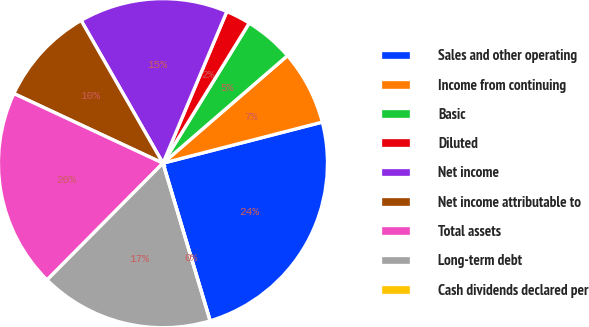Convert chart. <chart><loc_0><loc_0><loc_500><loc_500><pie_chart><fcel>Sales and other operating<fcel>Income from continuing<fcel>Basic<fcel>Diluted<fcel>Net income<fcel>Net income attributable to<fcel>Total assets<fcel>Long-term debt<fcel>Cash dividends declared per<nl><fcel>24.39%<fcel>7.32%<fcel>4.88%<fcel>2.44%<fcel>14.63%<fcel>9.76%<fcel>19.51%<fcel>17.07%<fcel>0.0%<nl></chart> 